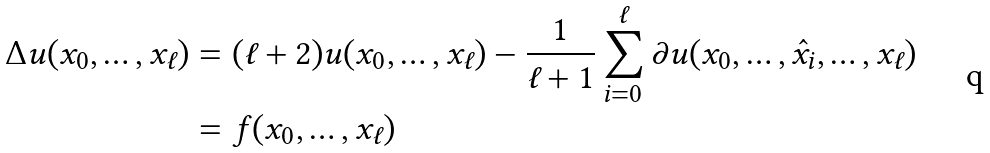Convert formula to latex. <formula><loc_0><loc_0><loc_500><loc_500>\Delta u ( x _ { 0 } , \dots , x _ { \ell } ) & = ( \ell + 2 ) u ( x _ { 0 } , \dots , x _ { \ell } ) - \frac { 1 } { \ell + 1 } \sum _ { i = 0 } ^ { \ell } \partial u ( x _ { 0 } , \dots , \hat { x } _ { i } , \dots , x _ { \ell } ) \\ & = f ( x _ { 0 } , \dots , x _ { \ell } )</formula> 